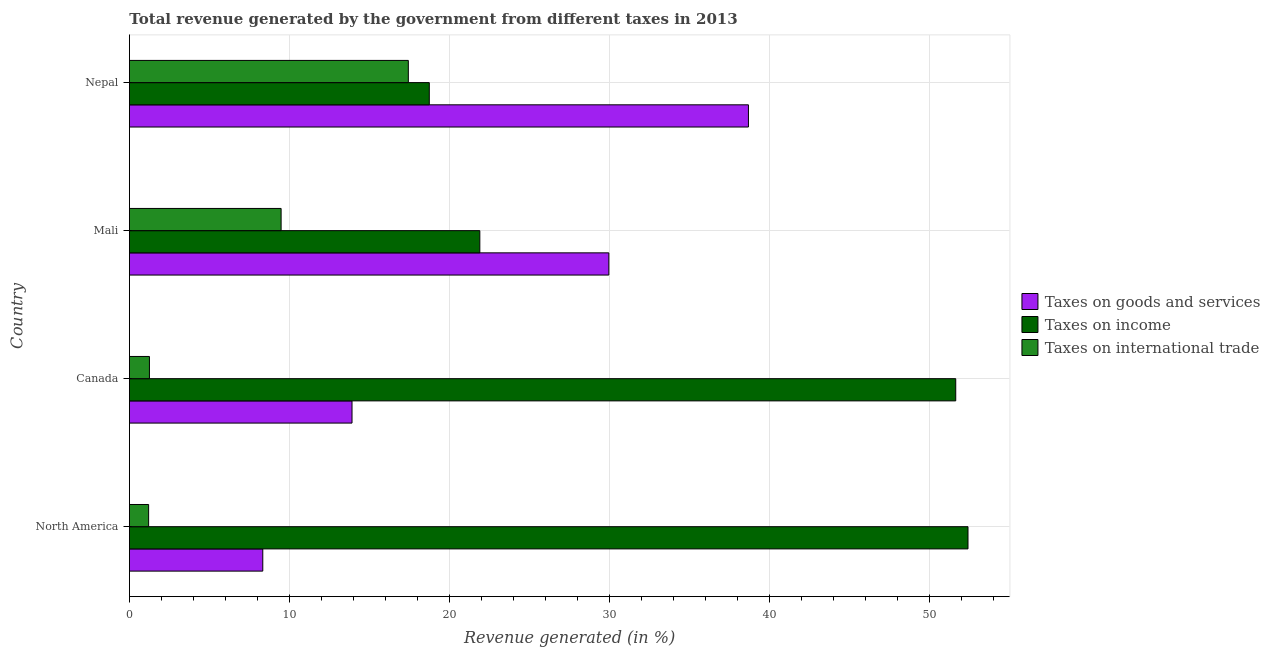How many groups of bars are there?
Provide a short and direct response. 4. How many bars are there on the 1st tick from the bottom?
Your answer should be very brief. 3. What is the label of the 2nd group of bars from the top?
Give a very brief answer. Mali. What is the percentage of revenue generated by taxes on goods and services in Mali?
Offer a terse response. 29.97. Across all countries, what is the maximum percentage of revenue generated by tax on international trade?
Your response must be concise. 17.43. Across all countries, what is the minimum percentage of revenue generated by taxes on goods and services?
Your answer should be compact. 8.34. In which country was the percentage of revenue generated by taxes on income minimum?
Your answer should be compact. Nepal. What is the total percentage of revenue generated by taxes on goods and services in the graph?
Ensure brevity in your answer.  90.91. What is the difference between the percentage of revenue generated by taxes on income in Canada and that in Nepal?
Your answer should be compact. 32.91. What is the difference between the percentage of revenue generated by tax on international trade in Mali and the percentage of revenue generated by taxes on income in North America?
Offer a terse response. -42.93. What is the average percentage of revenue generated by taxes on income per country?
Offer a terse response. 36.18. What is the difference between the percentage of revenue generated by tax on international trade and percentage of revenue generated by taxes on goods and services in Canada?
Give a very brief answer. -12.66. In how many countries, is the percentage of revenue generated by taxes on income greater than 34 %?
Offer a very short reply. 2. What is the ratio of the percentage of revenue generated by taxes on income in Mali to that in North America?
Your response must be concise. 0.42. Is the percentage of revenue generated by taxes on goods and services in Canada less than that in Mali?
Ensure brevity in your answer.  Yes. Is the difference between the percentage of revenue generated by tax on international trade in Mali and North America greater than the difference between the percentage of revenue generated by taxes on income in Mali and North America?
Give a very brief answer. Yes. What is the difference between the highest and the second highest percentage of revenue generated by taxes on goods and services?
Offer a very short reply. 8.73. What is the difference between the highest and the lowest percentage of revenue generated by tax on international trade?
Give a very brief answer. 16.23. What does the 1st bar from the top in Mali represents?
Your answer should be compact. Taxes on international trade. What does the 2nd bar from the bottom in Nepal represents?
Make the answer very short. Taxes on income. Is it the case that in every country, the sum of the percentage of revenue generated by taxes on goods and services and percentage of revenue generated by taxes on income is greater than the percentage of revenue generated by tax on international trade?
Offer a very short reply. Yes. How many bars are there?
Offer a very short reply. 12. How many countries are there in the graph?
Keep it short and to the point. 4. What is the difference between two consecutive major ticks on the X-axis?
Ensure brevity in your answer.  10. What is the title of the graph?
Ensure brevity in your answer.  Total revenue generated by the government from different taxes in 2013. Does "Transport" appear as one of the legend labels in the graph?
Provide a short and direct response. No. What is the label or title of the X-axis?
Keep it short and to the point. Revenue generated (in %). What is the label or title of the Y-axis?
Provide a short and direct response. Country. What is the Revenue generated (in %) of Taxes on goods and services in North America?
Give a very brief answer. 8.34. What is the Revenue generated (in %) of Taxes on income in North America?
Provide a succinct answer. 52.42. What is the Revenue generated (in %) in Taxes on international trade in North America?
Provide a succinct answer. 1.2. What is the Revenue generated (in %) in Taxes on goods and services in Canada?
Give a very brief answer. 13.91. What is the Revenue generated (in %) of Taxes on income in Canada?
Keep it short and to the point. 51.65. What is the Revenue generated (in %) of Taxes on international trade in Canada?
Keep it short and to the point. 1.25. What is the Revenue generated (in %) of Taxes on goods and services in Mali?
Offer a terse response. 29.97. What is the Revenue generated (in %) of Taxes on income in Mali?
Ensure brevity in your answer.  21.9. What is the Revenue generated (in %) in Taxes on international trade in Mali?
Provide a succinct answer. 9.48. What is the Revenue generated (in %) in Taxes on goods and services in Nepal?
Ensure brevity in your answer.  38.69. What is the Revenue generated (in %) of Taxes on income in Nepal?
Offer a terse response. 18.74. What is the Revenue generated (in %) in Taxes on international trade in Nepal?
Provide a succinct answer. 17.43. Across all countries, what is the maximum Revenue generated (in %) of Taxes on goods and services?
Ensure brevity in your answer.  38.69. Across all countries, what is the maximum Revenue generated (in %) of Taxes on income?
Your response must be concise. 52.42. Across all countries, what is the maximum Revenue generated (in %) in Taxes on international trade?
Ensure brevity in your answer.  17.43. Across all countries, what is the minimum Revenue generated (in %) in Taxes on goods and services?
Your answer should be compact. 8.34. Across all countries, what is the minimum Revenue generated (in %) of Taxes on income?
Give a very brief answer. 18.74. Across all countries, what is the minimum Revenue generated (in %) of Taxes on international trade?
Your answer should be compact. 1.2. What is the total Revenue generated (in %) in Taxes on goods and services in the graph?
Your answer should be very brief. 90.91. What is the total Revenue generated (in %) of Taxes on income in the graph?
Ensure brevity in your answer.  144.71. What is the total Revenue generated (in %) of Taxes on international trade in the graph?
Your answer should be compact. 29.37. What is the difference between the Revenue generated (in %) of Taxes on goods and services in North America and that in Canada?
Your response must be concise. -5.58. What is the difference between the Revenue generated (in %) of Taxes on income in North America and that in Canada?
Your answer should be compact. 0.77. What is the difference between the Revenue generated (in %) of Taxes on international trade in North America and that in Canada?
Offer a terse response. -0.05. What is the difference between the Revenue generated (in %) of Taxes on goods and services in North America and that in Mali?
Provide a short and direct response. -21.63. What is the difference between the Revenue generated (in %) in Taxes on income in North America and that in Mali?
Offer a terse response. 30.51. What is the difference between the Revenue generated (in %) of Taxes on international trade in North America and that in Mali?
Your answer should be compact. -8.28. What is the difference between the Revenue generated (in %) of Taxes on goods and services in North America and that in Nepal?
Ensure brevity in your answer.  -30.36. What is the difference between the Revenue generated (in %) of Taxes on income in North America and that in Nepal?
Make the answer very short. 33.67. What is the difference between the Revenue generated (in %) of Taxes on international trade in North America and that in Nepal?
Your answer should be very brief. -16.23. What is the difference between the Revenue generated (in %) in Taxes on goods and services in Canada and that in Mali?
Make the answer very short. -16.05. What is the difference between the Revenue generated (in %) in Taxes on income in Canada and that in Mali?
Your answer should be compact. 29.75. What is the difference between the Revenue generated (in %) in Taxes on international trade in Canada and that in Mali?
Offer a very short reply. -8.23. What is the difference between the Revenue generated (in %) of Taxes on goods and services in Canada and that in Nepal?
Provide a succinct answer. -24.78. What is the difference between the Revenue generated (in %) in Taxes on income in Canada and that in Nepal?
Provide a succinct answer. 32.9. What is the difference between the Revenue generated (in %) of Taxes on international trade in Canada and that in Nepal?
Your answer should be compact. -16.18. What is the difference between the Revenue generated (in %) in Taxes on goods and services in Mali and that in Nepal?
Make the answer very short. -8.73. What is the difference between the Revenue generated (in %) of Taxes on income in Mali and that in Nepal?
Offer a very short reply. 3.16. What is the difference between the Revenue generated (in %) in Taxes on international trade in Mali and that in Nepal?
Ensure brevity in your answer.  -7.95. What is the difference between the Revenue generated (in %) in Taxes on goods and services in North America and the Revenue generated (in %) in Taxes on income in Canada?
Your answer should be very brief. -43.31. What is the difference between the Revenue generated (in %) in Taxes on goods and services in North America and the Revenue generated (in %) in Taxes on international trade in Canada?
Provide a succinct answer. 7.08. What is the difference between the Revenue generated (in %) in Taxes on income in North America and the Revenue generated (in %) in Taxes on international trade in Canada?
Provide a succinct answer. 51.16. What is the difference between the Revenue generated (in %) of Taxes on goods and services in North America and the Revenue generated (in %) of Taxes on income in Mali?
Offer a terse response. -13.57. What is the difference between the Revenue generated (in %) in Taxes on goods and services in North America and the Revenue generated (in %) in Taxes on international trade in Mali?
Make the answer very short. -1.15. What is the difference between the Revenue generated (in %) of Taxes on income in North America and the Revenue generated (in %) of Taxes on international trade in Mali?
Provide a succinct answer. 42.93. What is the difference between the Revenue generated (in %) of Taxes on goods and services in North America and the Revenue generated (in %) of Taxes on income in Nepal?
Your response must be concise. -10.41. What is the difference between the Revenue generated (in %) of Taxes on goods and services in North America and the Revenue generated (in %) of Taxes on international trade in Nepal?
Provide a succinct answer. -9.1. What is the difference between the Revenue generated (in %) of Taxes on income in North America and the Revenue generated (in %) of Taxes on international trade in Nepal?
Your answer should be very brief. 34.98. What is the difference between the Revenue generated (in %) in Taxes on goods and services in Canada and the Revenue generated (in %) in Taxes on income in Mali?
Offer a very short reply. -7.99. What is the difference between the Revenue generated (in %) in Taxes on goods and services in Canada and the Revenue generated (in %) in Taxes on international trade in Mali?
Your answer should be very brief. 4.43. What is the difference between the Revenue generated (in %) in Taxes on income in Canada and the Revenue generated (in %) in Taxes on international trade in Mali?
Give a very brief answer. 42.17. What is the difference between the Revenue generated (in %) of Taxes on goods and services in Canada and the Revenue generated (in %) of Taxes on income in Nepal?
Provide a succinct answer. -4.83. What is the difference between the Revenue generated (in %) of Taxes on goods and services in Canada and the Revenue generated (in %) of Taxes on international trade in Nepal?
Your response must be concise. -3.52. What is the difference between the Revenue generated (in %) of Taxes on income in Canada and the Revenue generated (in %) of Taxes on international trade in Nepal?
Make the answer very short. 34.22. What is the difference between the Revenue generated (in %) in Taxes on goods and services in Mali and the Revenue generated (in %) in Taxes on income in Nepal?
Offer a very short reply. 11.22. What is the difference between the Revenue generated (in %) in Taxes on goods and services in Mali and the Revenue generated (in %) in Taxes on international trade in Nepal?
Your answer should be very brief. 12.53. What is the difference between the Revenue generated (in %) in Taxes on income in Mali and the Revenue generated (in %) in Taxes on international trade in Nepal?
Provide a succinct answer. 4.47. What is the average Revenue generated (in %) in Taxes on goods and services per country?
Provide a succinct answer. 22.73. What is the average Revenue generated (in %) in Taxes on income per country?
Your answer should be very brief. 36.18. What is the average Revenue generated (in %) of Taxes on international trade per country?
Your answer should be very brief. 7.34. What is the difference between the Revenue generated (in %) of Taxes on goods and services and Revenue generated (in %) of Taxes on income in North America?
Provide a succinct answer. -44.08. What is the difference between the Revenue generated (in %) of Taxes on goods and services and Revenue generated (in %) of Taxes on international trade in North America?
Offer a very short reply. 7.14. What is the difference between the Revenue generated (in %) of Taxes on income and Revenue generated (in %) of Taxes on international trade in North America?
Offer a very short reply. 51.21. What is the difference between the Revenue generated (in %) in Taxes on goods and services and Revenue generated (in %) in Taxes on income in Canada?
Make the answer very short. -37.73. What is the difference between the Revenue generated (in %) in Taxes on goods and services and Revenue generated (in %) in Taxes on international trade in Canada?
Provide a short and direct response. 12.66. What is the difference between the Revenue generated (in %) of Taxes on income and Revenue generated (in %) of Taxes on international trade in Canada?
Give a very brief answer. 50.4. What is the difference between the Revenue generated (in %) of Taxes on goods and services and Revenue generated (in %) of Taxes on income in Mali?
Your response must be concise. 8.06. What is the difference between the Revenue generated (in %) in Taxes on goods and services and Revenue generated (in %) in Taxes on international trade in Mali?
Make the answer very short. 20.48. What is the difference between the Revenue generated (in %) in Taxes on income and Revenue generated (in %) in Taxes on international trade in Mali?
Provide a short and direct response. 12.42. What is the difference between the Revenue generated (in %) in Taxes on goods and services and Revenue generated (in %) in Taxes on income in Nepal?
Make the answer very short. 19.95. What is the difference between the Revenue generated (in %) of Taxes on goods and services and Revenue generated (in %) of Taxes on international trade in Nepal?
Your response must be concise. 21.26. What is the difference between the Revenue generated (in %) in Taxes on income and Revenue generated (in %) in Taxes on international trade in Nepal?
Your answer should be compact. 1.31. What is the ratio of the Revenue generated (in %) of Taxes on goods and services in North America to that in Canada?
Ensure brevity in your answer.  0.6. What is the ratio of the Revenue generated (in %) in Taxes on income in North America to that in Canada?
Your response must be concise. 1.01. What is the ratio of the Revenue generated (in %) in Taxes on international trade in North America to that in Canada?
Offer a very short reply. 0.96. What is the ratio of the Revenue generated (in %) of Taxes on goods and services in North America to that in Mali?
Your answer should be compact. 0.28. What is the ratio of the Revenue generated (in %) of Taxes on income in North America to that in Mali?
Offer a terse response. 2.39. What is the ratio of the Revenue generated (in %) of Taxes on international trade in North America to that in Mali?
Provide a succinct answer. 0.13. What is the ratio of the Revenue generated (in %) in Taxes on goods and services in North America to that in Nepal?
Your answer should be very brief. 0.22. What is the ratio of the Revenue generated (in %) of Taxes on income in North America to that in Nepal?
Provide a succinct answer. 2.8. What is the ratio of the Revenue generated (in %) of Taxes on international trade in North America to that in Nepal?
Keep it short and to the point. 0.07. What is the ratio of the Revenue generated (in %) in Taxes on goods and services in Canada to that in Mali?
Keep it short and to the point. 0.46. What is the ratio of the Revenue generated (in %) in Taxes on income in Canada to that in Mali?
Give a very brief answer. 2.36. What is the ratio of the Revenue generated (in %) in Taxes on international trade in Canada to that in Mali?
Give a very brief answer. 0.13. What is the ratio of the Revenue generated (in %) in Taxes on goods and services in Canada to that in Nepal?
Provide a succinct answer. 0.36. What is the ratio of the Revenue generated (in %) in Taxes on income in Canada to that in Nepal?
Make the answer very short. 2.76. What is the ratio of the Revenue generated (in %) in Taxes on international trade in Canada to that in Nepal?
Offer a very short reply. 0.07. What is the ratio of the Revenue generated (in %) in Taxes on goods and services in Mali to that in Nepal?
Make the answer very short. 0.77. What is the ratio of the Revenue generated (in %) in Taxes on income in Mali to that in Nepal?
Give a very brief answer. 1.17. What is the ratio of the Revenue generated (in %) of Taxes on international trade in Mali to that in Nepal?
Your answer should be very brief. 0.54. What is the difference between the highest and the second highest Revenue generated (in %) in Taxes on goods and services?
Make the answer very short. 8.73. What is the difference between the highest and the second highest Revenue generated (in %) in Taxes on income?
Your answer should be compact. 0.77. What is the difference between the highest and the second highest Revenue generated (in %) of Taxes on international trade?
Your answer should be very brief. 7.95. What is the difference between the highest and the lowest Revenue generated (in %) of Taxes on goods and services?
Your answer should be compact. 30.36. What is the difference between the highest and the lowest Revenue generated (in %) in Taxes on income?
Your answer should be compact. 33.67. What is the difference between the highest and the lowest Revenue generated (in %) of Taxes on international trade?
Offer a very short reply. 16.23. 